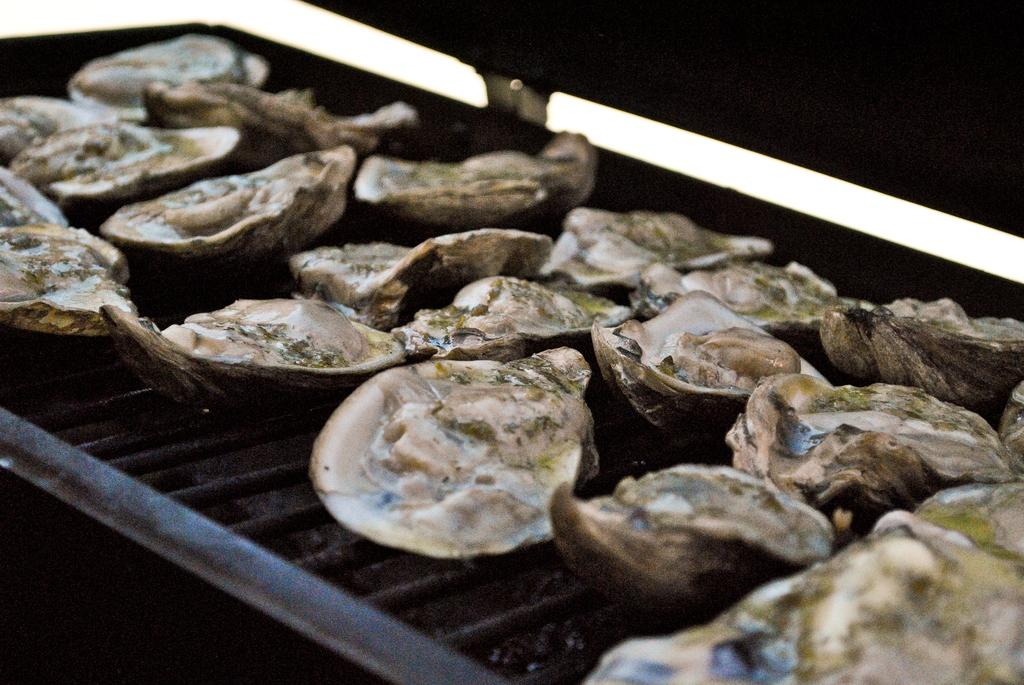What type of seafood is featured in the image? There are Chilean oysters in the image. What is the color of the grill tray that the oysters are on? The grill tray is black in color. What type of juice is being squeezed out of the oysters in the image? There is no juice being squeezed out of the oysters in the image; it only features the oysters on a black grill tray. 